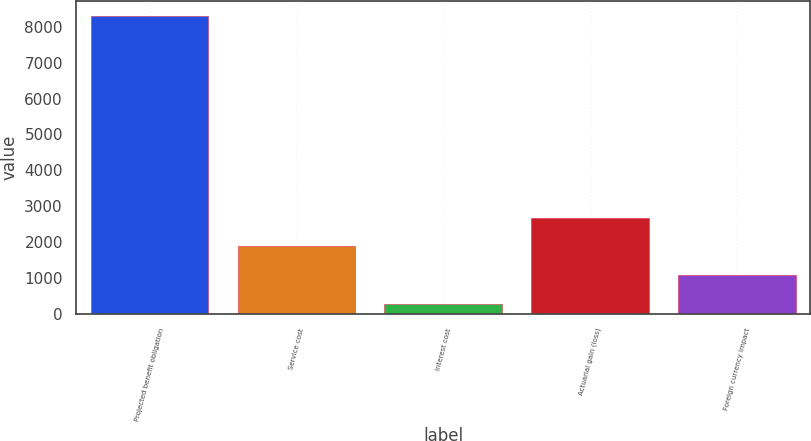<chart> <loc_0><loc_0><loc_500><loc_500><bar_chart><fcel>Projected benefit obligation<fcel>Service cost<fcel>Interest cost<fcel>Actuarial gain (loss)<fcel>Foreign currency impact<nl><fcel>8300<fcel>1884<fcel>280<fcel>2686<fcel>1082<nl></chart> 